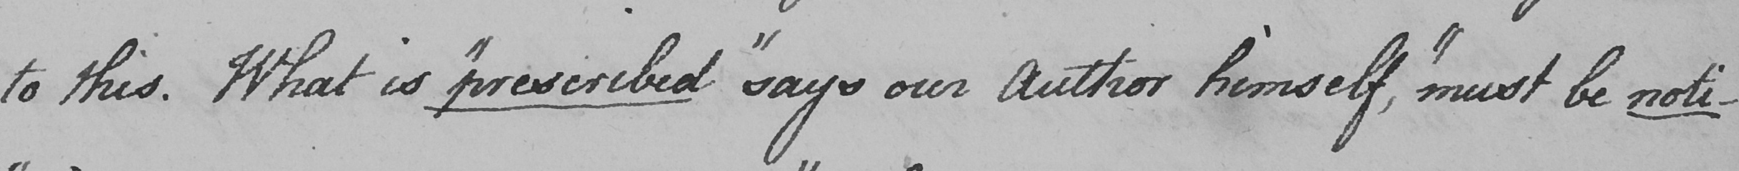Please transcribe the handwritten text in this image. to this . What is  " prescribed "  says our Author himself ,  " must be noti- 